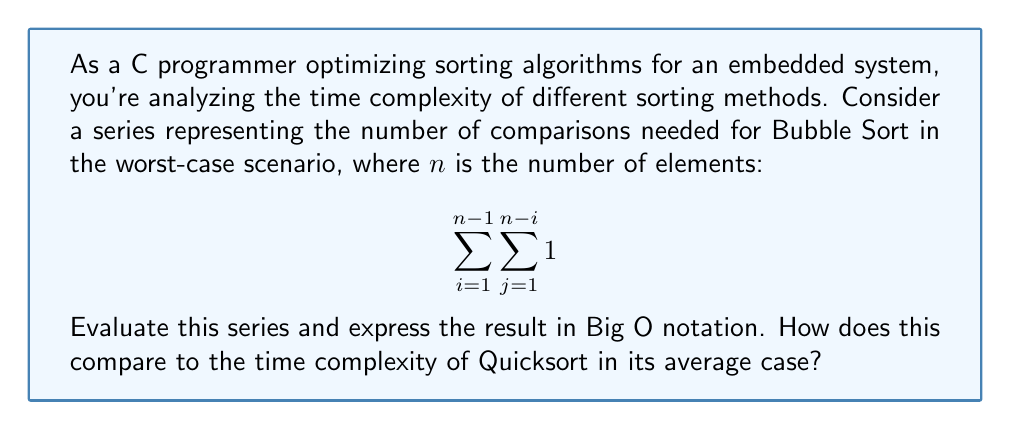Could you help me with this problem? Let's break this down step-by-step:

1) The inner sum $\sum_{j=1}^{n-i} 1$ is simply counting from 1 to $n-i$, so it evaluates to $n-i$.

2) Now our series becomes:

   $$\sum_{i=1}^{n-1} (n-i)$$

3) We can rewrite this as:

   $$\sum_{i=1}^{n-1} n - \sum_{i=1}^{n-1} i$$

4) The first sum is simply $n(n-1)$.

5) The second sum is the well-known series $\frac{n(n-1)}{2}$.

6) Therefore, our result is:

   $$n(n-1) - \frac{n(n-1)}{2} = \frac{n(n-1)}{2}$$

7) Expanding this:

   $$\frac{n^2 - n}{2}$$

8) In Big O notation, we only care about the highest order term, so this is $O(n^2)$.

9) Quicksort, in its average case, has a time complexity of $O(n \log n)$.

10) Comparing these, we can see that Bubble Sort ($O(n^2)$) is less efficient than Quicksort ($O(n \log n)$) for large datasets.
Answer: The series evaluates to $\frac{n^2 - n}{2}$, which is $O(n^2)$ in Big O notation. This is less efficient than Quicksort's average case of $O(n \log n)$. 